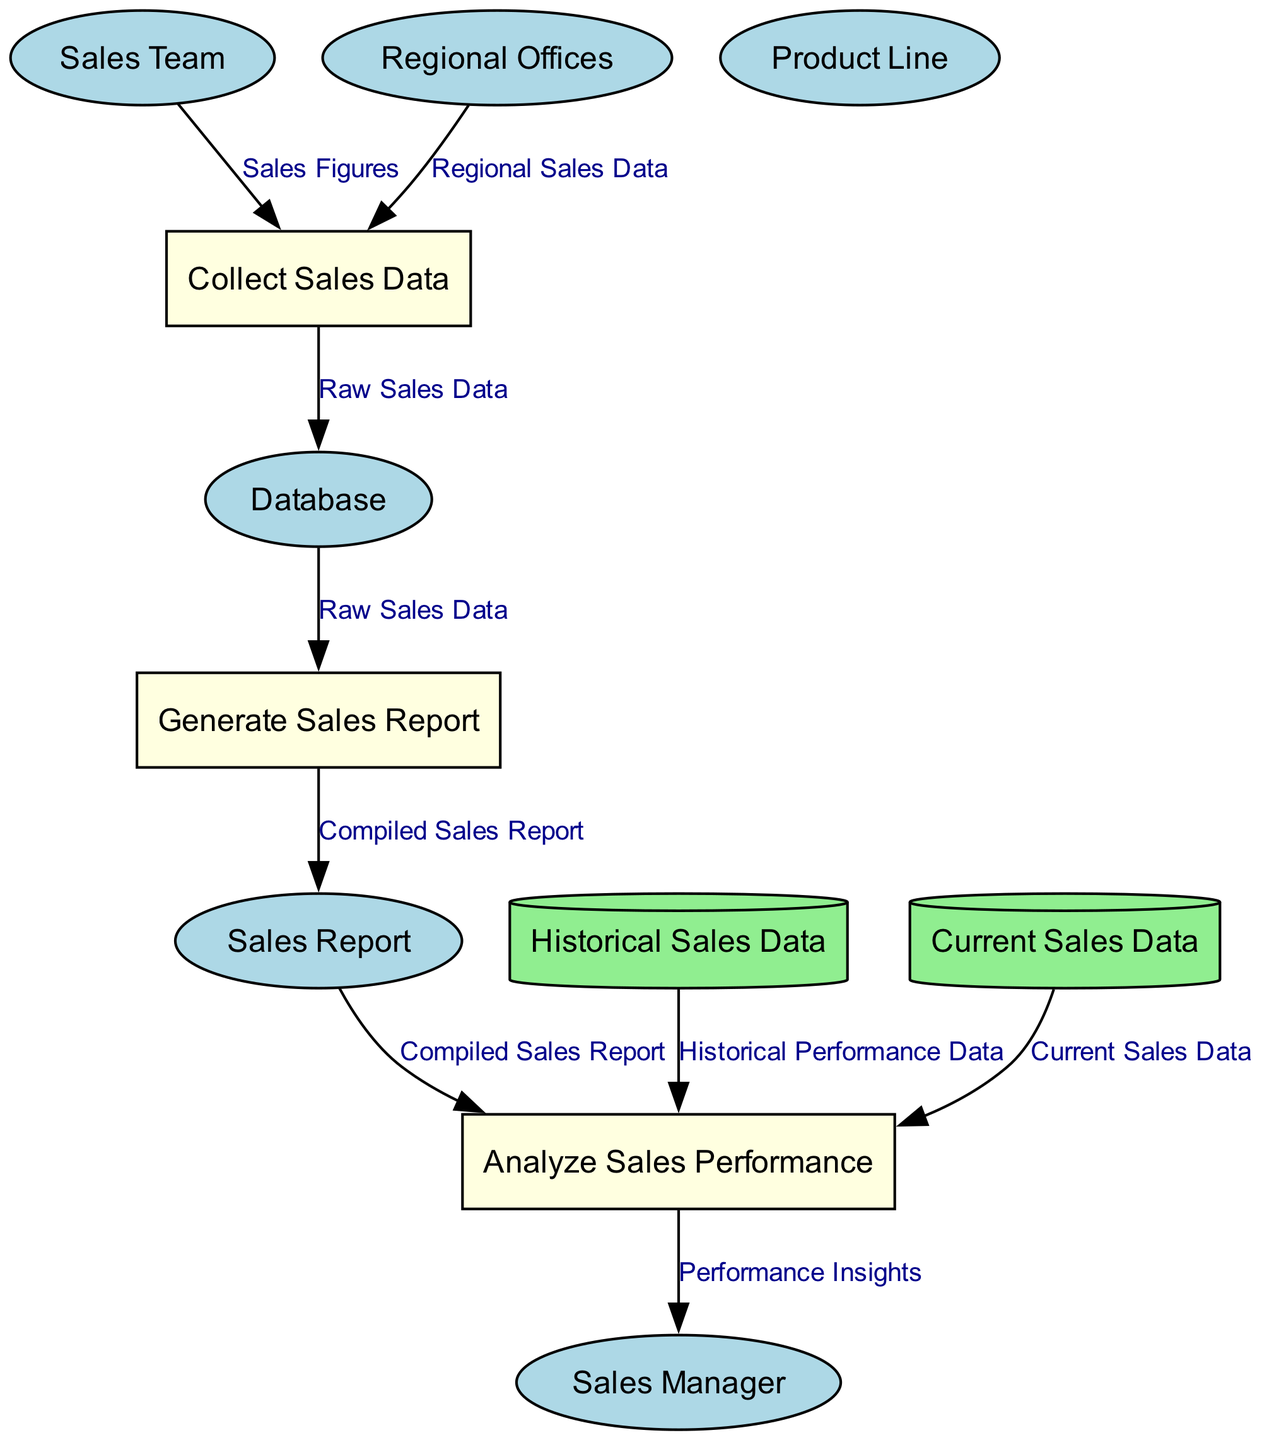What is the name of the Sales Report entity? The diagram lists an entity called "Sales Report", which is responsible for holding the compiled sales data broken down by product and region.
Answer: Sales Report How many processes are there in the diagram? The diagram presents three distinct processes: "Collect Sales Data", "Generate Sales Report", and "Analyze Sales Performance". Therefore, the total count of processes is three.
Answer: 3 Which entity provides sales figures to "Collect Sales Data"? The "Sales Team" entity is depicted as supplying "Sales Figures" to the "Collect Sales Data" process in the diagram.
Answer: Sales Team What data flows from "Database" to "Generate Sales Report"? According to the diagram, "Raw Sales Data" is the data that flows from the "Database" to the "Generate Sales Report" process.
Answer: Raw Sales Data What is the destination of the data flow from "Sales Report"? The data from "Sales Report" flows to the "Analyze Sales Performance" process, as indicated in the diagram.
Answer: Analyze Sales Performance Which data stores are involved in analyzing sales performance? The diagram shows that both "Historical Sales Data" and "Current Sales Data" are involved in the "Analyze Sales Performance" process.
Answer: Historical Sales Data, Current Sales Data What type of diagram is represented? The diagram type is a Data Flow Diagram, which depicts the flow of information through various processes, entities, and data stores in the context of sales performance assessment.
Answer: Data Flow Diagram Who evaluates overall sales performance based on reports? The "Sales Manager" entity is designated in the diagram as the party evaluating overall sales performance based on reports and experience.
Answer: Sales Manager What is the role of Regional Offices in the diagram? Regional Offices are responsible for providing regional sales data to the "Collect Sales Data" process, as depicted in the diagram.
Answer: Providing regional sales data 